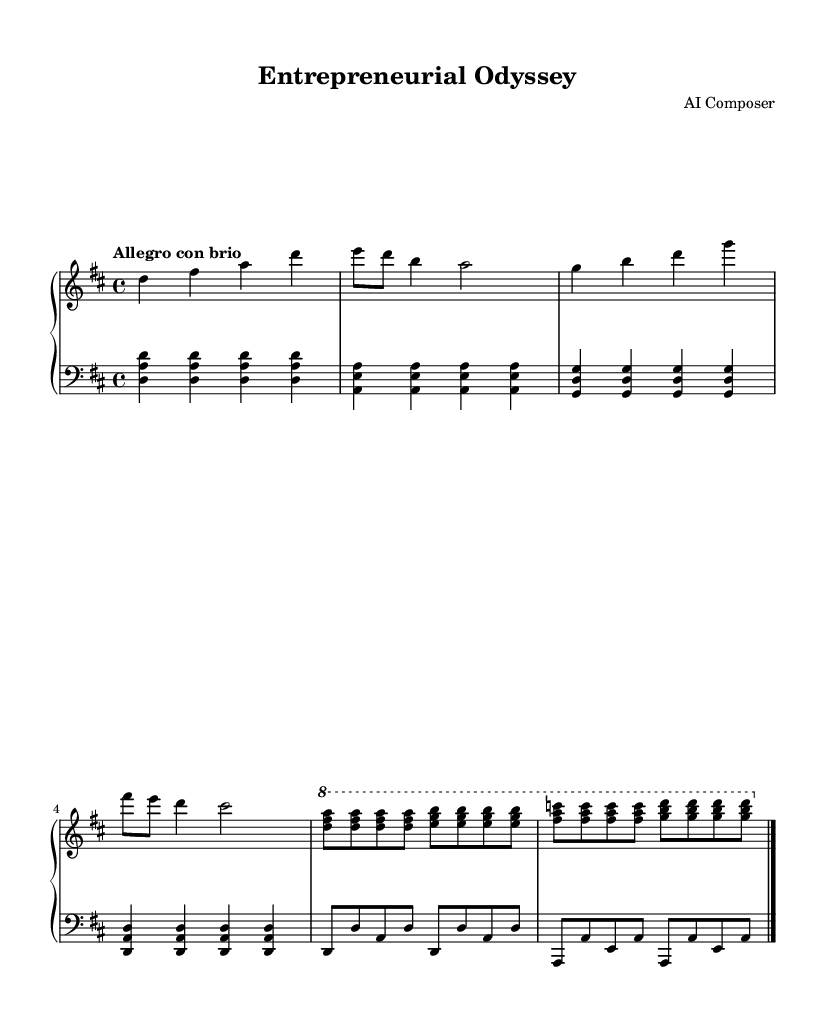What is the key signature of this music? The key signature is D major, which has two sharps: F# and C#. This can be identified by checking the key signature section indicated at the beginning of the music.
Answer: D major What is the time signature of this piece? The time signature is 4/4, which means there are four beats in a measure and the quarter note gets one beat. This information can be found next to the clef symbol at the start of the music.
Answer: 4/4 What is the tempo marking written in the score? The tempo marking indicates "Allegro con brio," suggesting a lively and spirited performance. This marking is usually placed at the beginning of the piece or section.
Answer: Allegro con brio How many measures are there in the right hand part? The right hand part consists of 8 measures, which can be counted by identifying the bar lines that separate each measure.
Answer: 8 What is the interval between the first two notes in the right hand? The interval between the first two notes (D and F#) is a major third. This can be determined by analyzing the distance between the notes on the staff.
Answer: Major third How does the left hand complement the right hand? The left hand provides harmonic support with sustained chords that align with the right hand's melodic line, enhancing the overall texture of the music. This relationship can be observed through coordination of notes played simultaneously across both hands.
Answer: Harmonic support What is the frequency of repeated notes in the left hand? The left hand features repeated notes primarily on D, observed through the repeating pattern across multiple measures which establishes a rhythmic foundation.
Answer: Repeated D 